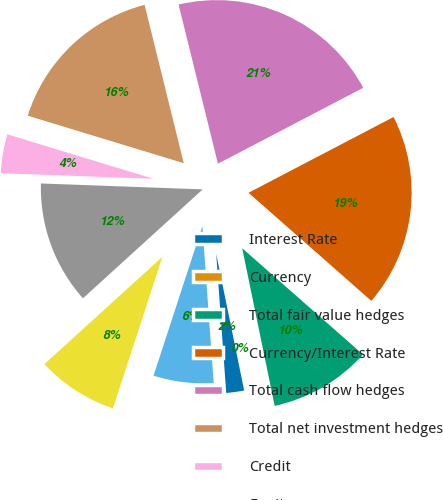Convert chart to OTSL. <chart><loc_0><loc_0><loc_500><loc_500><pie_chart><fcel>Interest Rate<fcel>Currency<fcel>Total fair value hedges<fcel>Currency/Interest Rate<fcel>Total cash flow hedges<fcel>Total net investment hedges<fcel>Credit<fcel>Equity<fcel>Other<fcel>Embedded Derivatives<nl><fcel>2.07%<fcel>0.02%<fcel>10.28%<fcel>19.15%<fcel>21.2%<fcel>16.44%<fcel>4.12%<fcel>12.33%<fcel>8.23%<fcel>6.17%<nl></chart> 